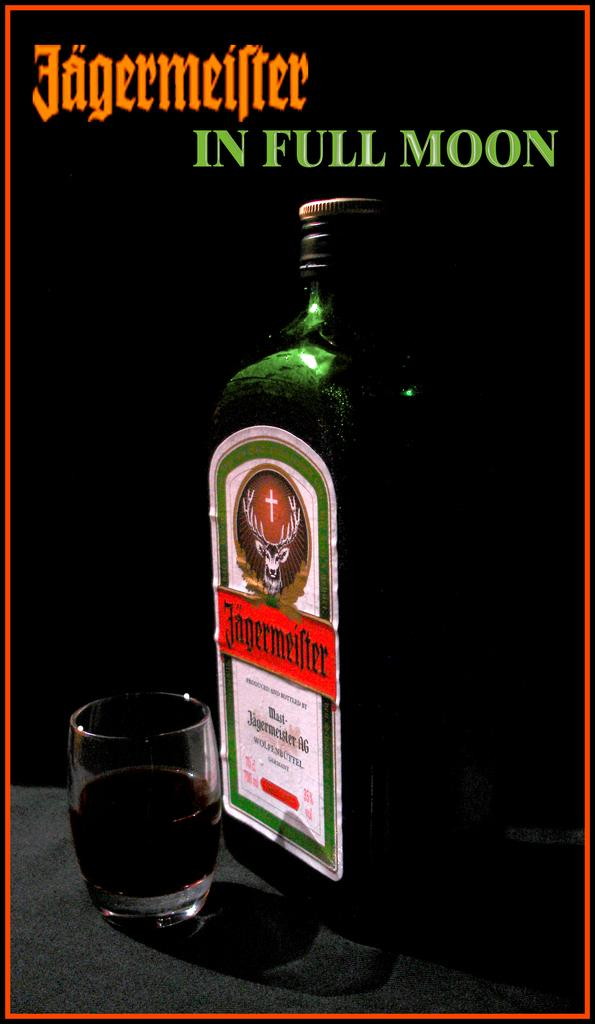<image>
Render a clear and concise summary of the photo. A ad for a product called Jagermeifler in Full Moon. 